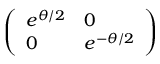<formula> <loc_0><loc_0><loc_500><loc_500>\left ( \begin{array} { l l } { e ^ { \theta / 2 } } & { 0 } \\ { 0 } & { e ^ { - \theta / 2 } } \end{array} \right )</formula> 